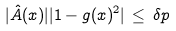Convert formula to latex. <formula><loc_0><loc_0><loc_500><loc_500>| \hat { A } ( x ) | | 1 - g ( x ) ^ { 2 } | \, \leq \, \delta p</formula> 